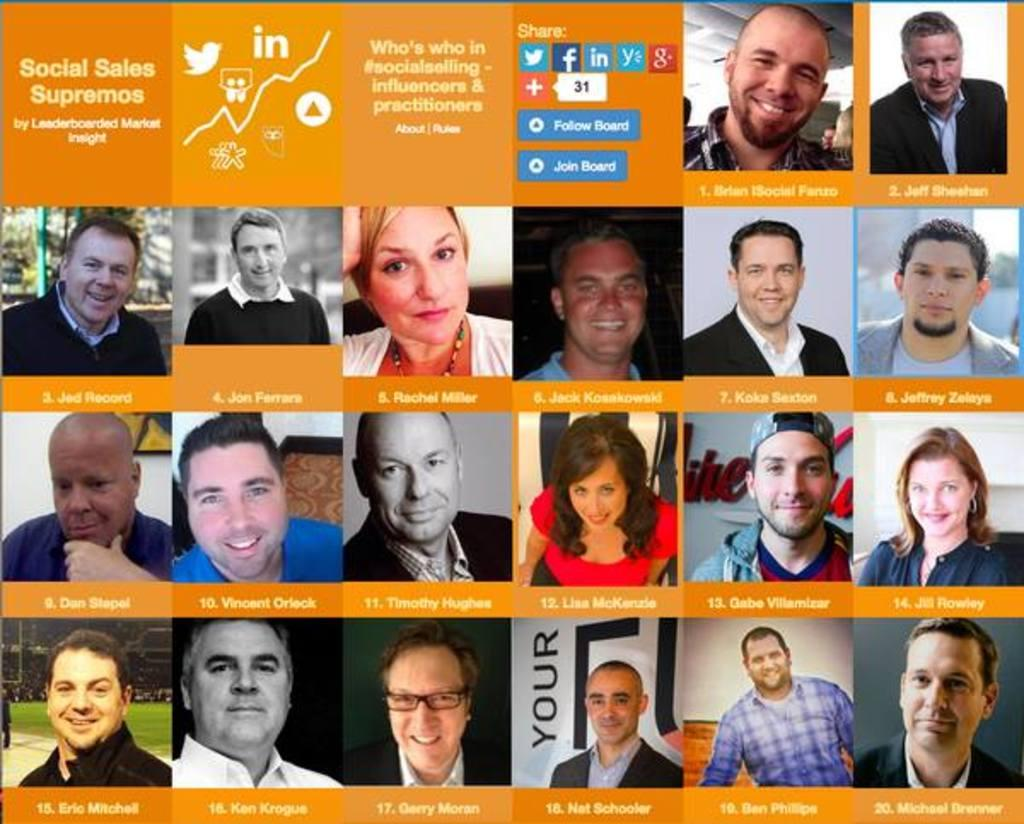What is the main subject of the image? The main subject of the image is a collage of pictures. What additional information is included in the collage? There are names on the collage. Are there any other elements visible in the image? Yes, there are application icons on the left top of the image. Can you see any cords connected to the collage in the image? There are no cords visible in the image; it only shows a collage of pictures, names, and application icons. 